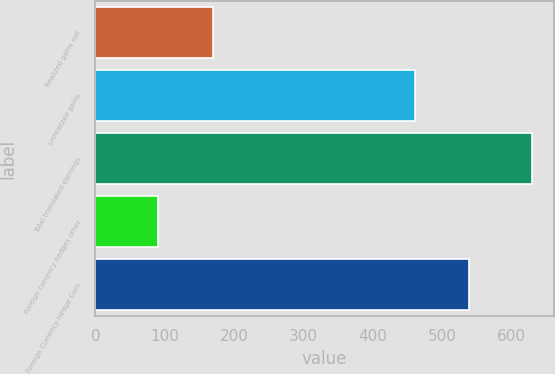<chart> <loc_0><loc_0><loc_500><loc_500><bar_chart><fcel>Realized gains net<fcel>Unrealized gains<fcel>Total translated earnings<fcel>Foreign currency hedges other<fcel>Foreign Currency Hedge Gain<nl><fcel>169<fcel>460<fcel>629<fcel>91<fcel>538<nl></chart> 